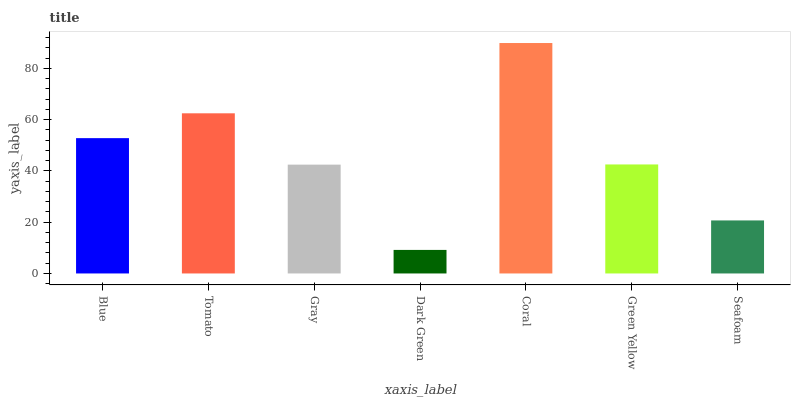Is Dark Green the minimum?
Answer yes or no. Yes. Is Coral the maximum?
Answer yes or no. Yes. Is Tomato the minimum?
Answer yes or no. No. Is Tomato the maximum?
Answer yes or no. No. Is Tomato greater than Blue?
Answer yes or no. Yes. Is Blue less than Tomato?
Answer yes or no. Yes. Is Blue greater than Tomato?
Answer yes or no. No. Is Tomato less than Blue?
Answer yes or no. No. Is Green Yellow the high median?
Answer yes or no. Yes. Is Green Yellow the low median?
Answer yes or no. Yes. Is Gray the high median?
Answer yes or no. No. Is Seafoam the low median?
Answer yes or no. No. 